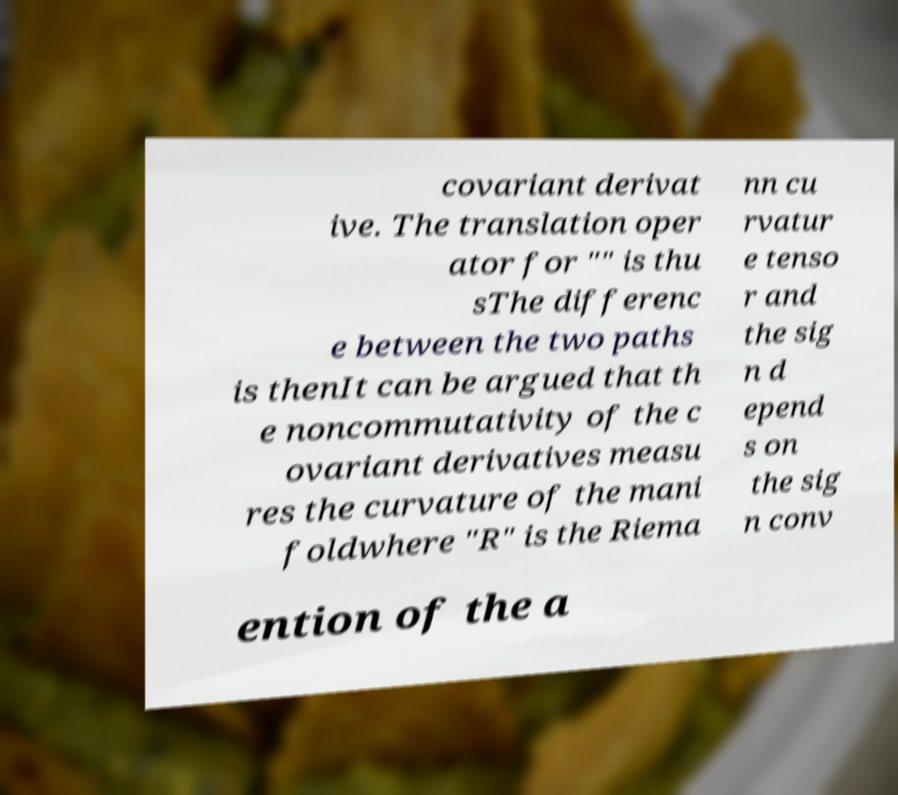What messages or text are displayed in this image? I need them in a readable, typed format. covariant derivat ive. The translation oper ator for "" is thu sThe differenc e between the two paths is thenIt can be argued that th e noncommutativity of the c ovariant derivatives measu res the curvature of the mani foldwhere "R" is the Riema nn cu rvatur e tenso r and the sig n d epend s on the sig n conv ention of the a 